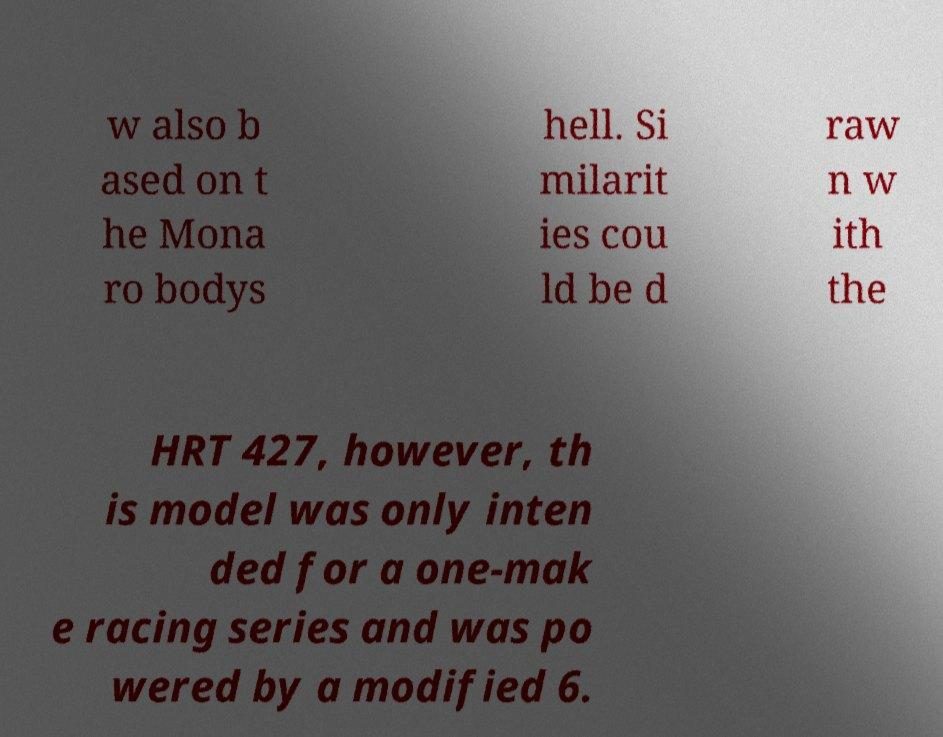Can you read and provide the text displayed in the image?This photo seems to have some interesting text. Can you extract and type it out for me? w also b ased on t he Mona ro bodys hell. Si milarit ies cou ld be d raw n w ith the HRT 427, however, th is model was only inten ded for a one-mak e racing series and was po wered by a modified 6. 